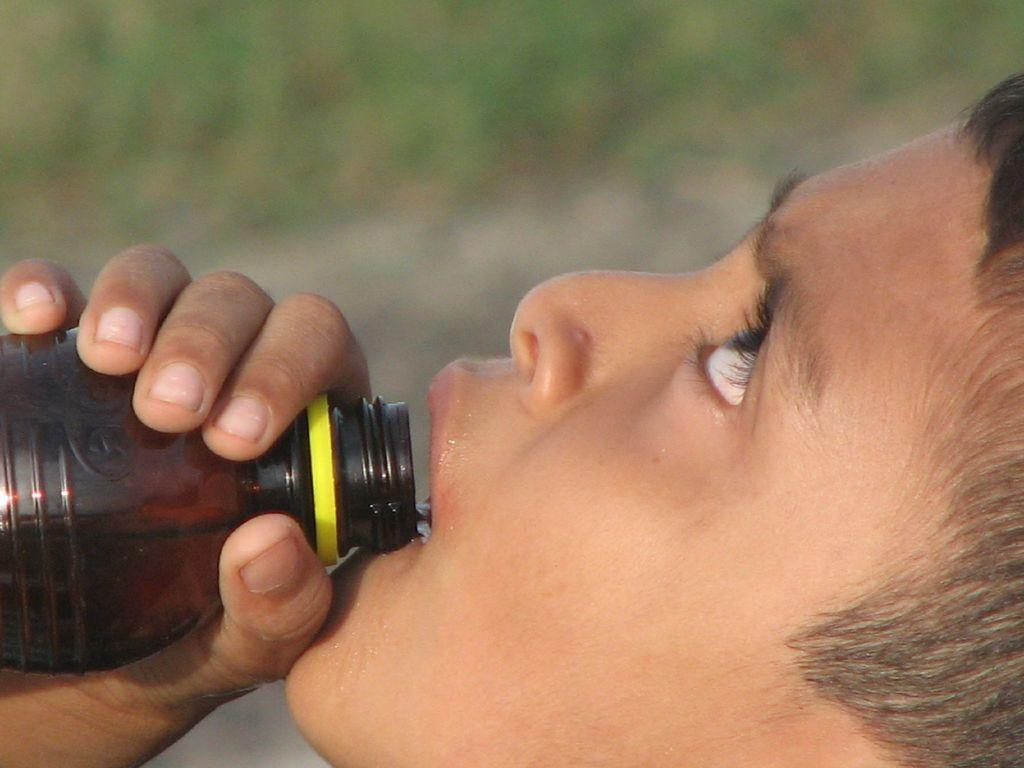Who is present in the image? There is a person in the image. What is the person doing in the image? The person is drinking water. What color is the bottle that the person is using? The bottle is black-colored. What can be seen in the background of the image? There are trees in the background of the image. How is the background of the image depicted? The background is blurred. What type of toy can be seen in the image? There is no toy present in the image. Is there any evidence of a crack in the bottle in the image? There is no crack visible in the black-colored bottle in the image. 